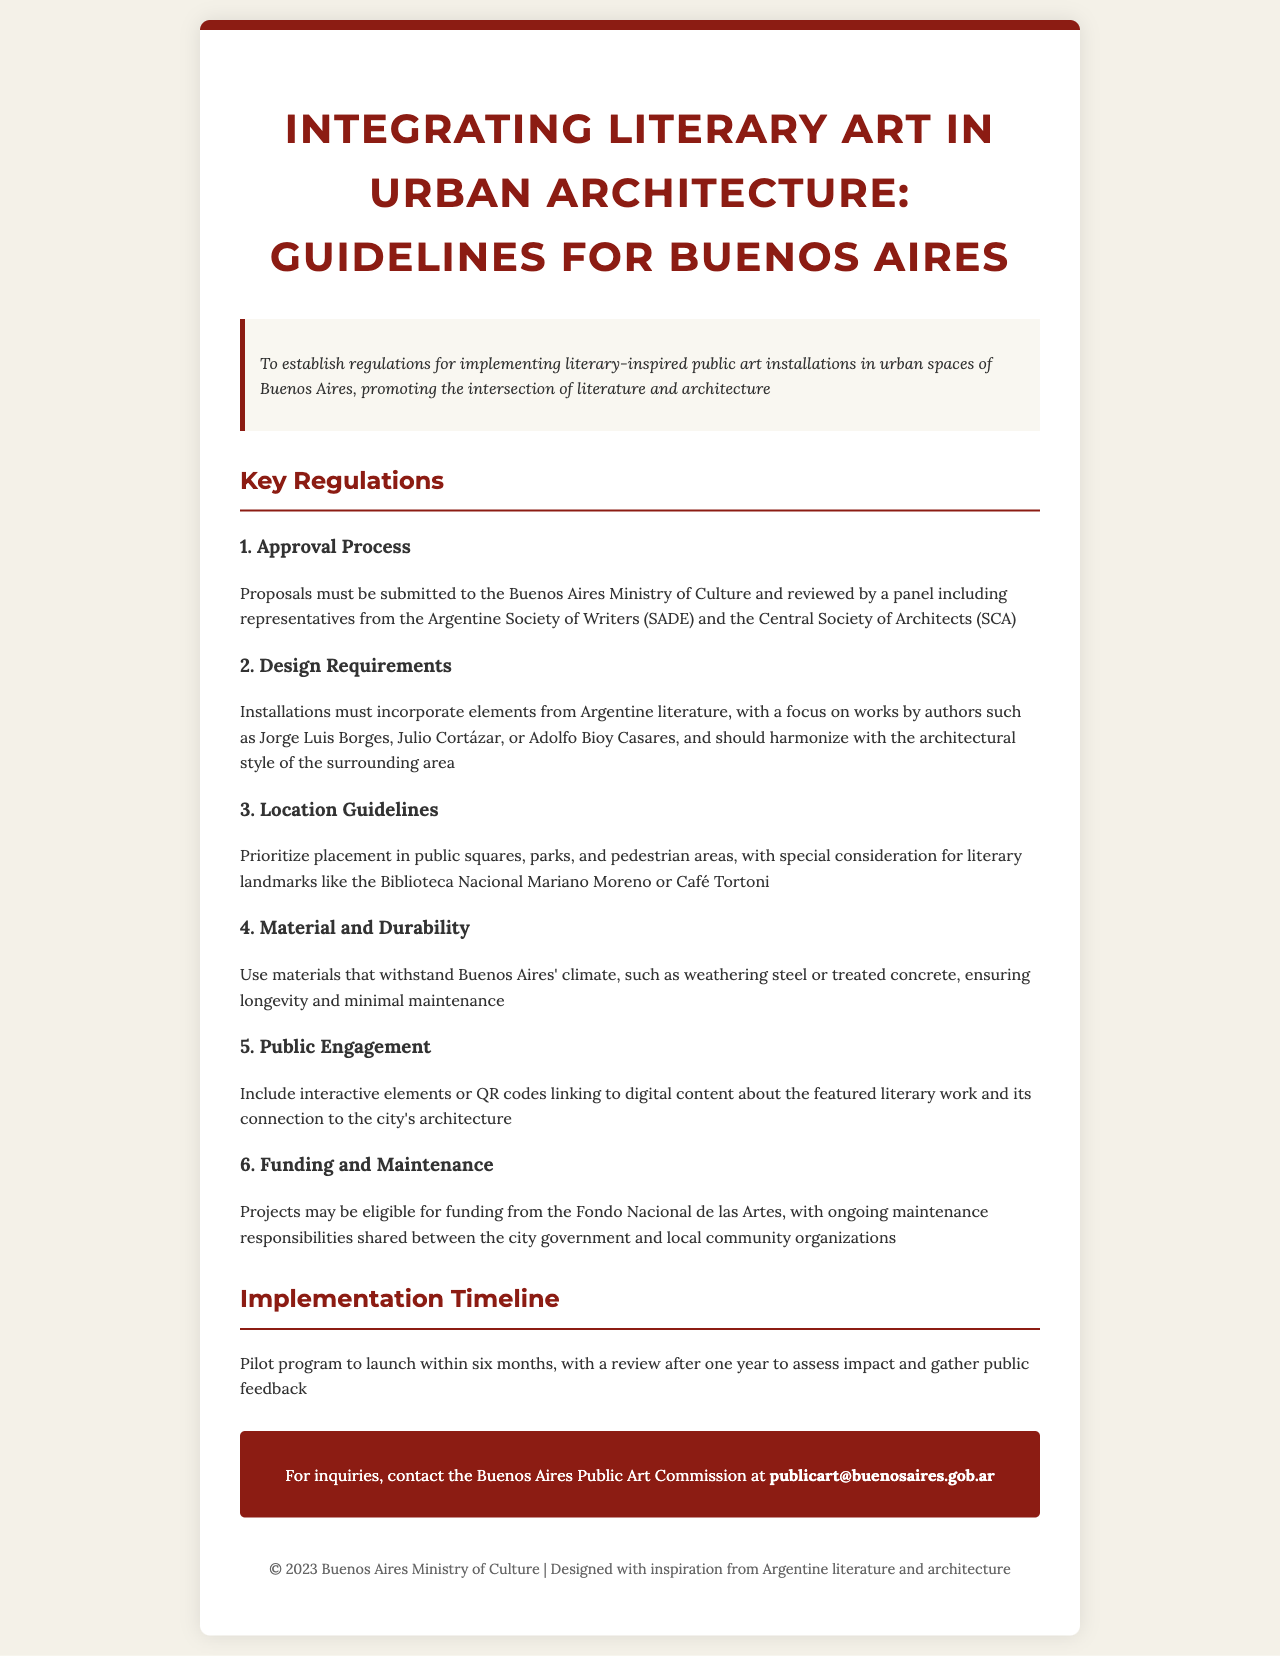What is the title of the document? The title of the document is clearly stated at the beginning of the rendered document.
Answer: Integrating Literary Art in Urban Architecture: Guidelines for Buenos Aires Who must review the proposals? The document specifies that a panel, including representatives from the Argentine Society of Writers (SADE) and the Central Society of Architects (SCA), must review the proposals.
Answer: Panel What materials are recommended for the installations? The document outlines specific materials recommended for durability against the climate of Buenos Aires.
Answer: Weathering steel or treated concrete Where should the installations be prioritized? The document provides a guideline on preferred locations for the installations, suggesting specific types of public spaces.
Answer: Public squares, parks, and pedestrian areas How long is the pilot program planned to launch? The implementation timeline indicates the duration before the pilot program is expected to launch.
Answer: Six months What element should be included for public engagement? The document mentions an important interactive feature that should be part of the installations to engage the public.
Answer: Interactive elements or QR codes Which notable literary landmarks are mentioned for location consideration? The document lists specific literary landmarks that should be considered for placement of installations.
Answer: Biblioteca Nacional Mariano Moreno or Café Tortoni What funding source is mentioned for the projects? The document specifies a funding source that may be available for the art projects.
Answer: Fondo Nacional de las Artes 